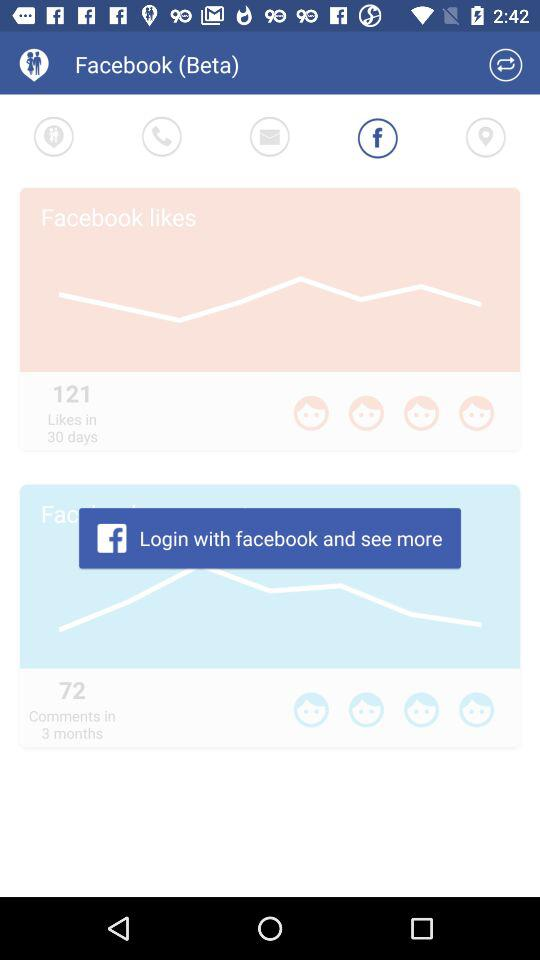How many likes in 30 days? There are 121 likes in 30 days. 